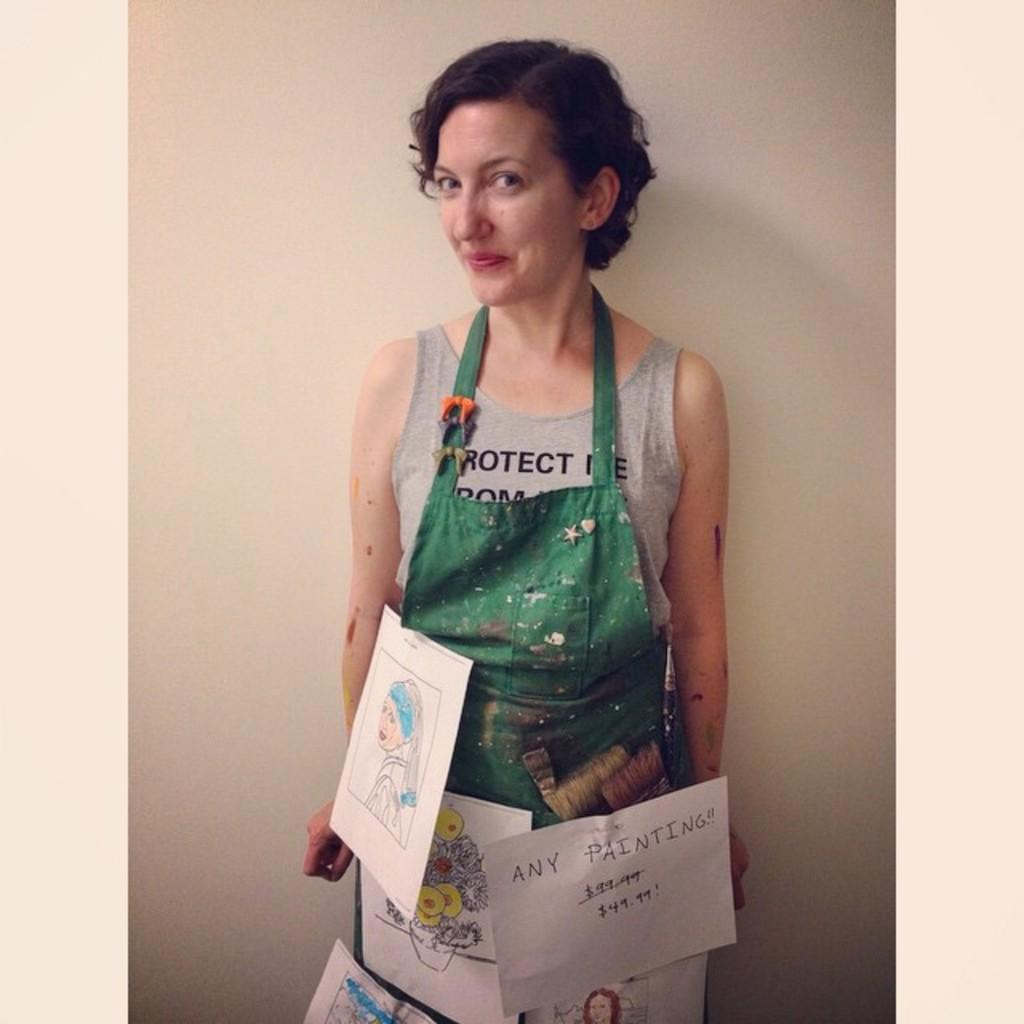Who is the main subject in the image? There is a woman in the image. What is the woman wearing? The woman is wearing a gray t-shirt. Are there any designs or images on the woman's t-shirt? Yes, the woman's t-shirt has different posters on it. What is the woman's facial expression in the image? The woman is smiling. What is the woman's posture in the image? The woman is standing. What can be seen in the background of the image? There is a white wall in the background of the image. What book is the woman reading in the image? There is no book present in the image; the woman is wearing a t-shirt with posters on it. What type of ray is visible in the image? There is no ray present in the image. 